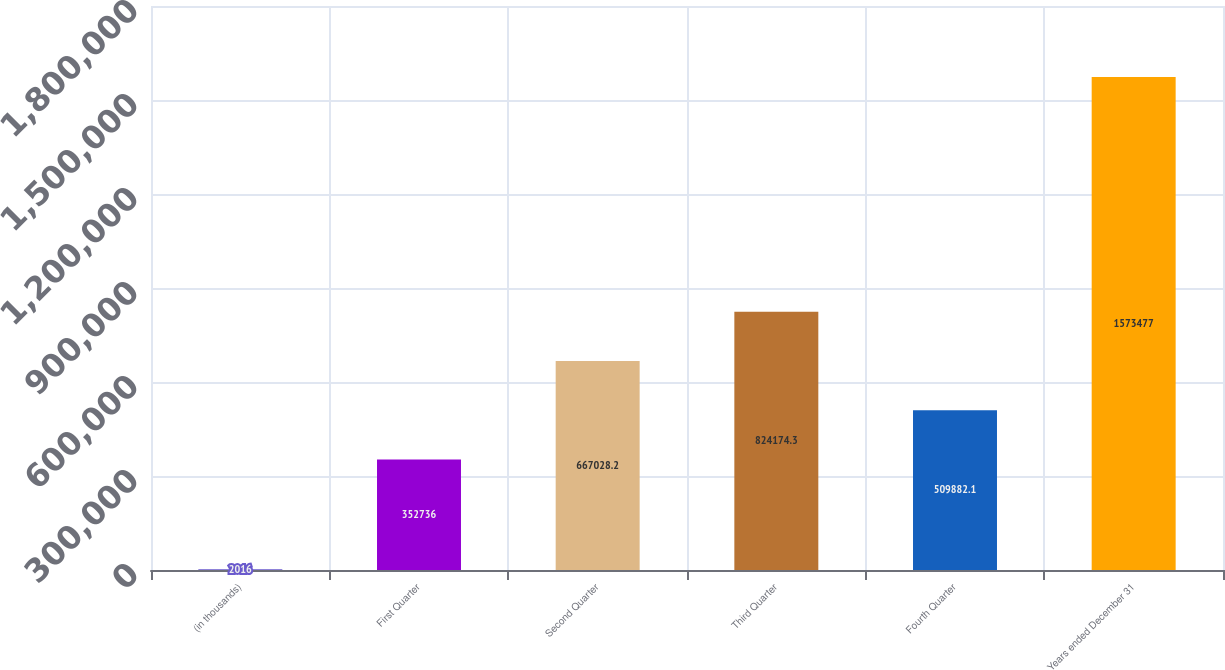Convert chart to OTSL. <chart><loc_0><loc_0><loc_500><loc_500><bar_chart><fcel>(in thousands)<fcel>First Quarter<fcel>Second Quarter<fcel>Third Quarter<fcel>Fourth Quarter<fcel>Years ended December 31<nl><fcel>2016<fcel>352736<fcel>667028<fcel>824174<fcel>509882<fcel>1.57348e+06<nl></chart> 